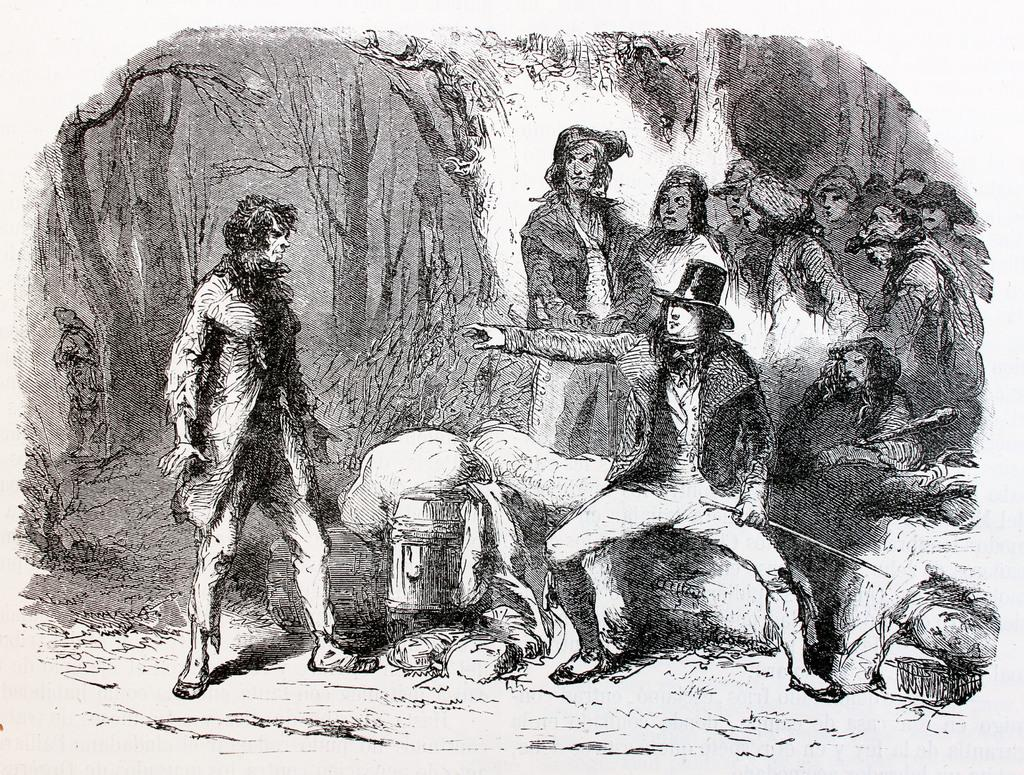What is present in the image? There is a paper in the image. What can be found on the paper? The paper contains a drawing of humans. How does the paper breathe in the image? The paper does not breathe in the image, as it is an inanimate object. 